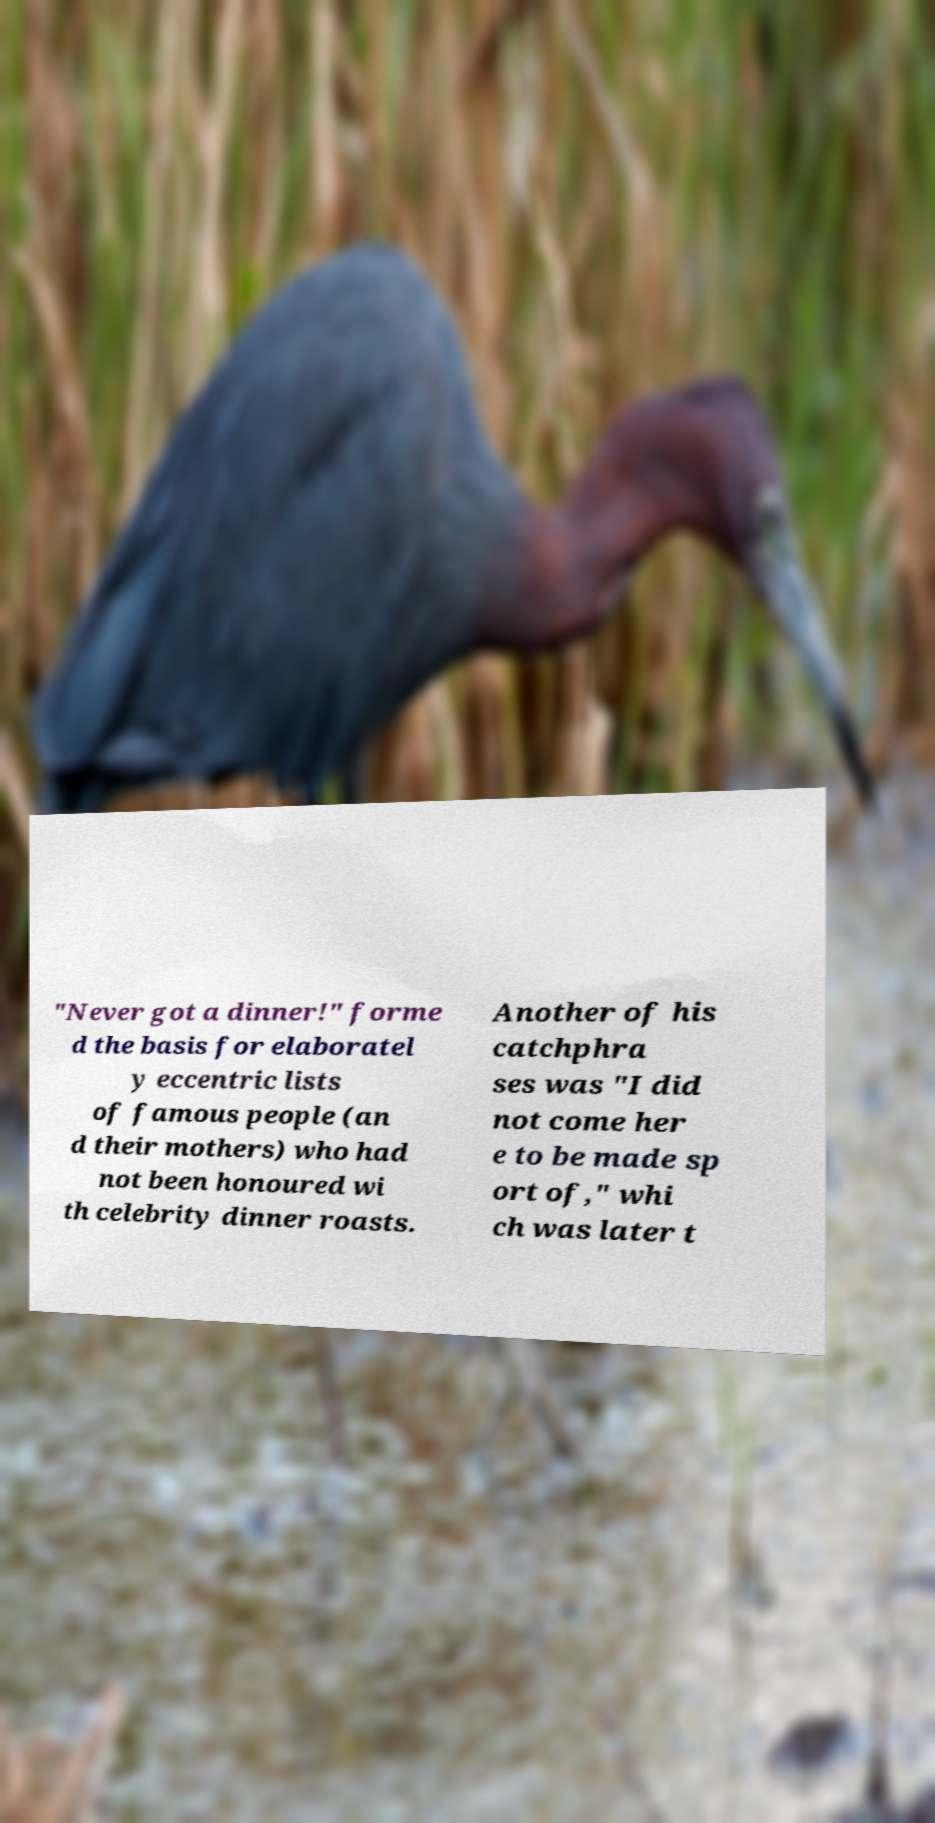What messages or text are displayed in this image? I need them in a readable, typed format. "Never got a dinner!" forme d the basis for elaboratel y eccentric lists of famous people (an d their mothers) who had not been honoured wi th celebrity dinner roasts. Another of his catchphra ses was "I did not come her e to be made sp ort of," whi ch was later t 